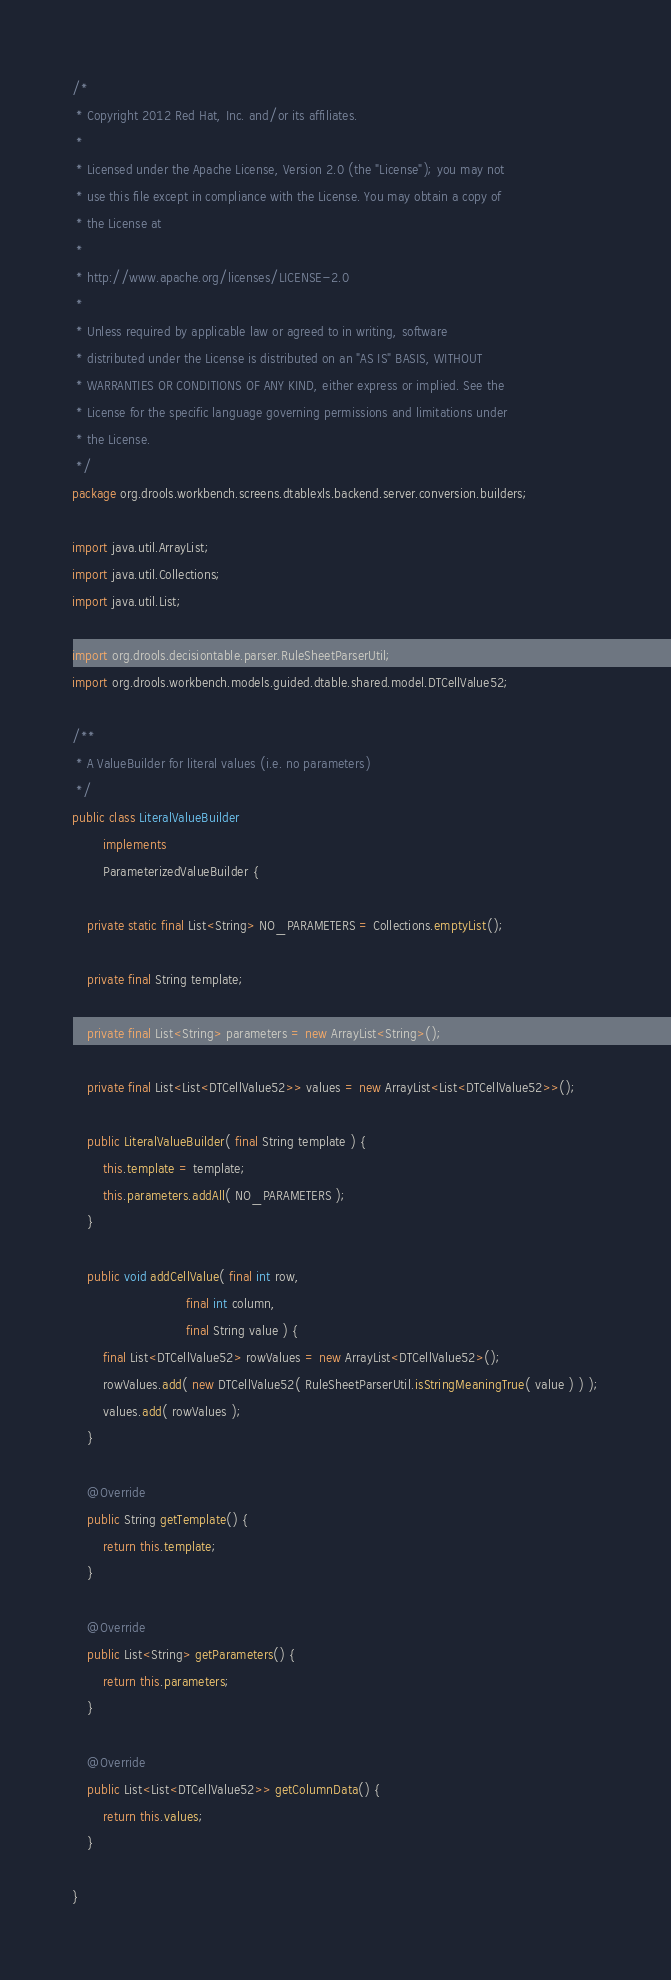Convert code to text. <code><loc_0><loc_0><loc_500><loc_500><_Java_>/*
 * Copyright 2012 Red Hat, Inc. and/or its affiliates.
 * 
 * Licensed under the Apache License, Version 2.0 (the "License"); you may not
 * use this file except in compliance with the License. You may obtain a copy of
 * the License at
 * 
 * http://www.apache.org/licenses/LICENSE-2.0
 * 
 * Unless required by applicable law or agreed to in writing, software
 * distributed under the License is distributed on an "AS IS" BASIS, WITHOUT
 * WARRANTIES OR CONDITIONS OF ANY KIND, either express or implied. See the
 * License for the specific language governing permissions and limitations under
 * the License.
 */
package org.drools.workbench.screens.dtablexls.backend.server.conversion.builders;

import java.util.ArrayList;
import java.util.Collections;
import java.util.List;

import org.drools.decisiontable.parser.RuleSheetParserUtil;
import org.drools.workbench.models.guided.dtable.shared.model.DTCellValue52;

/**
 * A ValueBuilder for literal values (i.e. no parameters)
 */
public class LiteralValueBuilder
        implements
        ParameterizedValueBuilder {

    private static final List<String> NO_PARAMETERS = Collections.emptyList();

    private final String template;

    private final List<String> parameters = new ArrayList<String>();

    private final List<List<DTCellValue52>> values = new ArrayList<List<DTCellValue52>>();

    public LiteralValueBuilder( final String template ) {
        this.template = template;
        this.parameters.addAll( NO_PARAMETERS );
    }

    public void addCellValue( final int row,
                              final int column,
                              final String value ) {
        final List<DTCellValue52> rowValues = new ArrayList<DTCellValue52>();
        rowValues.add( new DTCellValue52( RuleSheetParserUtil.isStringMeaningTrue( value ) ) );
        values.add( rowValues );
    }

    @Override
    public String getTemplate() {
        return this.template;
    }

    @Override
    public List<String> getParameters() {
        return this.parameters;
    }

    @Override
    public List<List<DTCellValue52>> getColumnData() {
        return this.values;
    }

}
</code> 